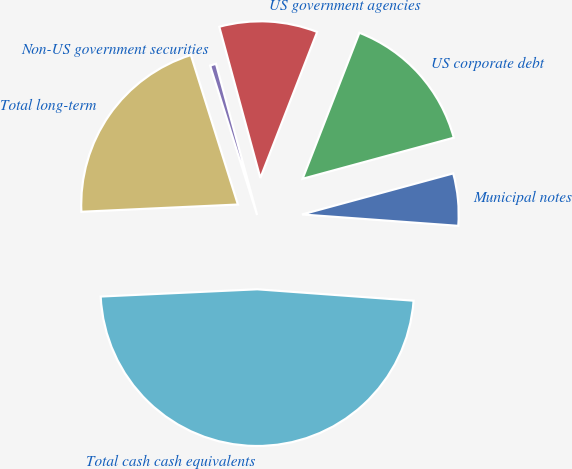<chart> <loc_0><loc_0><loc_500><loc_500><pie_chart><fcel>Municipal notes<fcel>US corporate debt<fcel>US government agencies<fcel>Non-US government securities<fcel>Total long-term<fcel>Total cash cash equivalents<nl><fcel>5.38%<fcel>14.87%<fcel>10.13%<fcel>0.63%<fcel>20.88%<fcel>48.1%<nl></chart> 